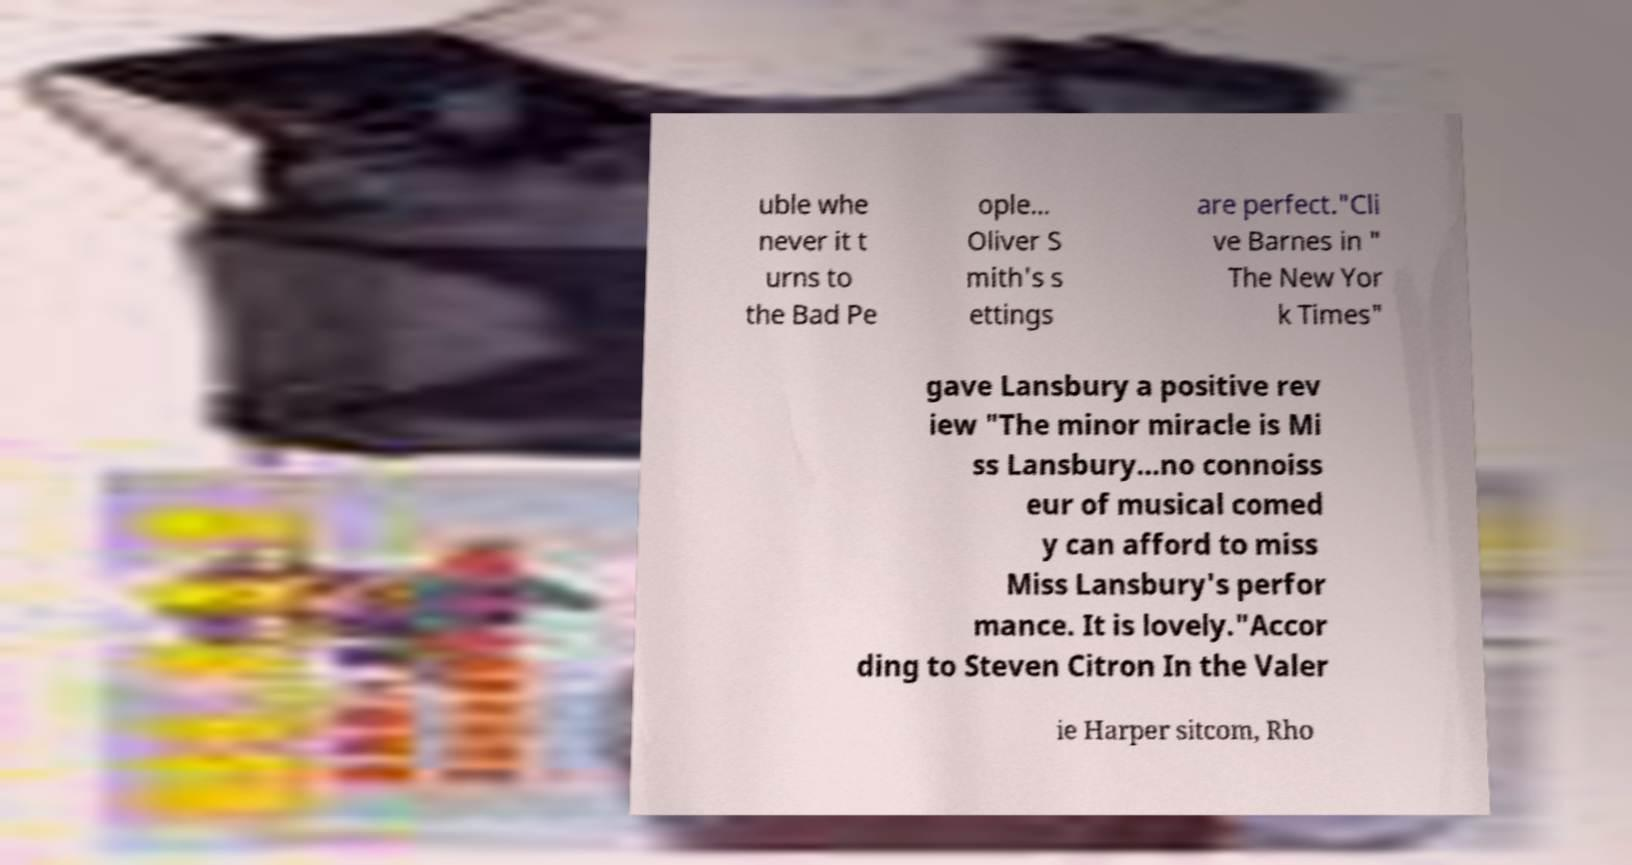For documentation purposes, I need the text within this image transcribed. Could you provide that? uble whe never it t urns to the Bad Pe ople... Oliver S mith's s ettings are perfect."Cli ve Barnes in " The New Yor k Times" gave Lansbury a positive rev iew "The minor miracle is Mi ss Lansbury...no connoiss eur of musical comed y can afford to miss Miss Lansbury's perfor mance. It is lovely."Accor ding to Steven Citron In the Valer ie Harper sitcom, Rho 